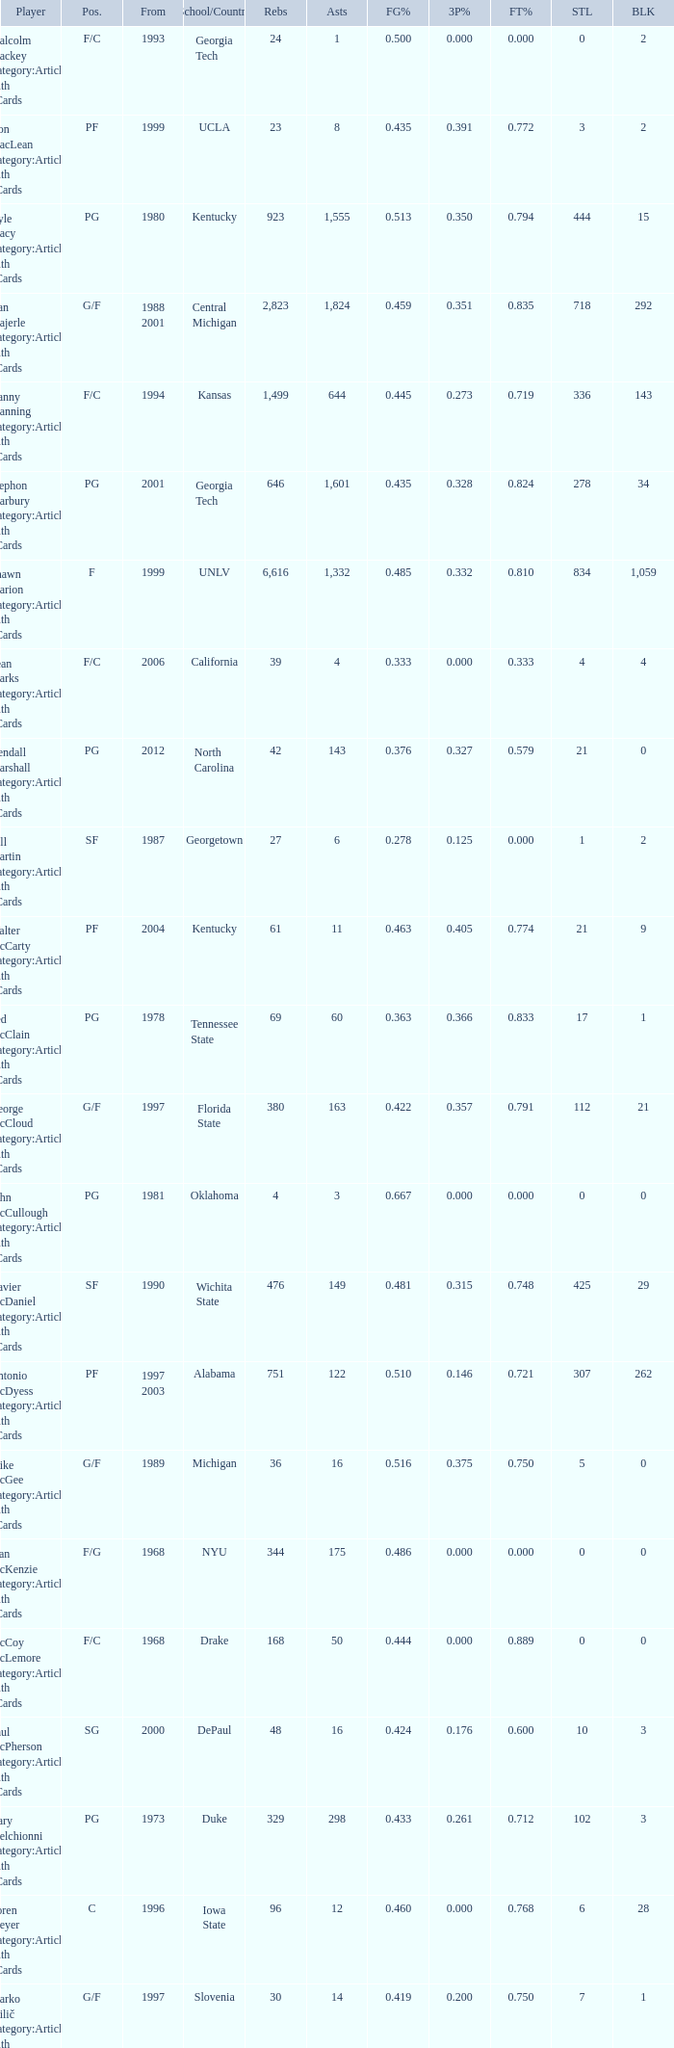What position does the player from arkansas play? C. 